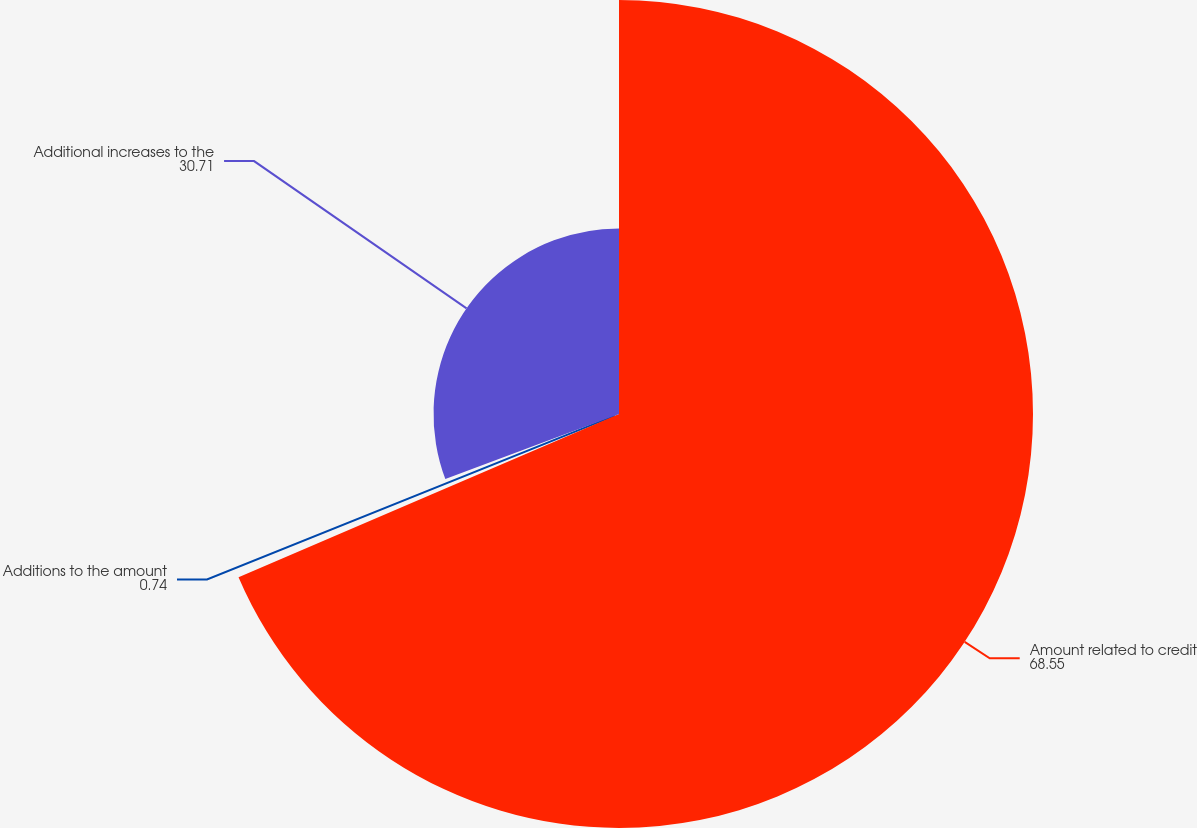Convert chart. <chart><loc_0><loc_0><loc_500><loc_500><pie_chart><fcel>Amount related to credit<fcel>Additions to the amount<fcel>Additional increases to the<nl><fcel>68.55%<fcel>0.74%<fcel>30.71%<nl></chart> 